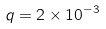Convert formula to latex. <formula><loc_0><loc_0><loc_500><loc_500>q = 2 \times 1 0 ^ { - 3 }</formula> 